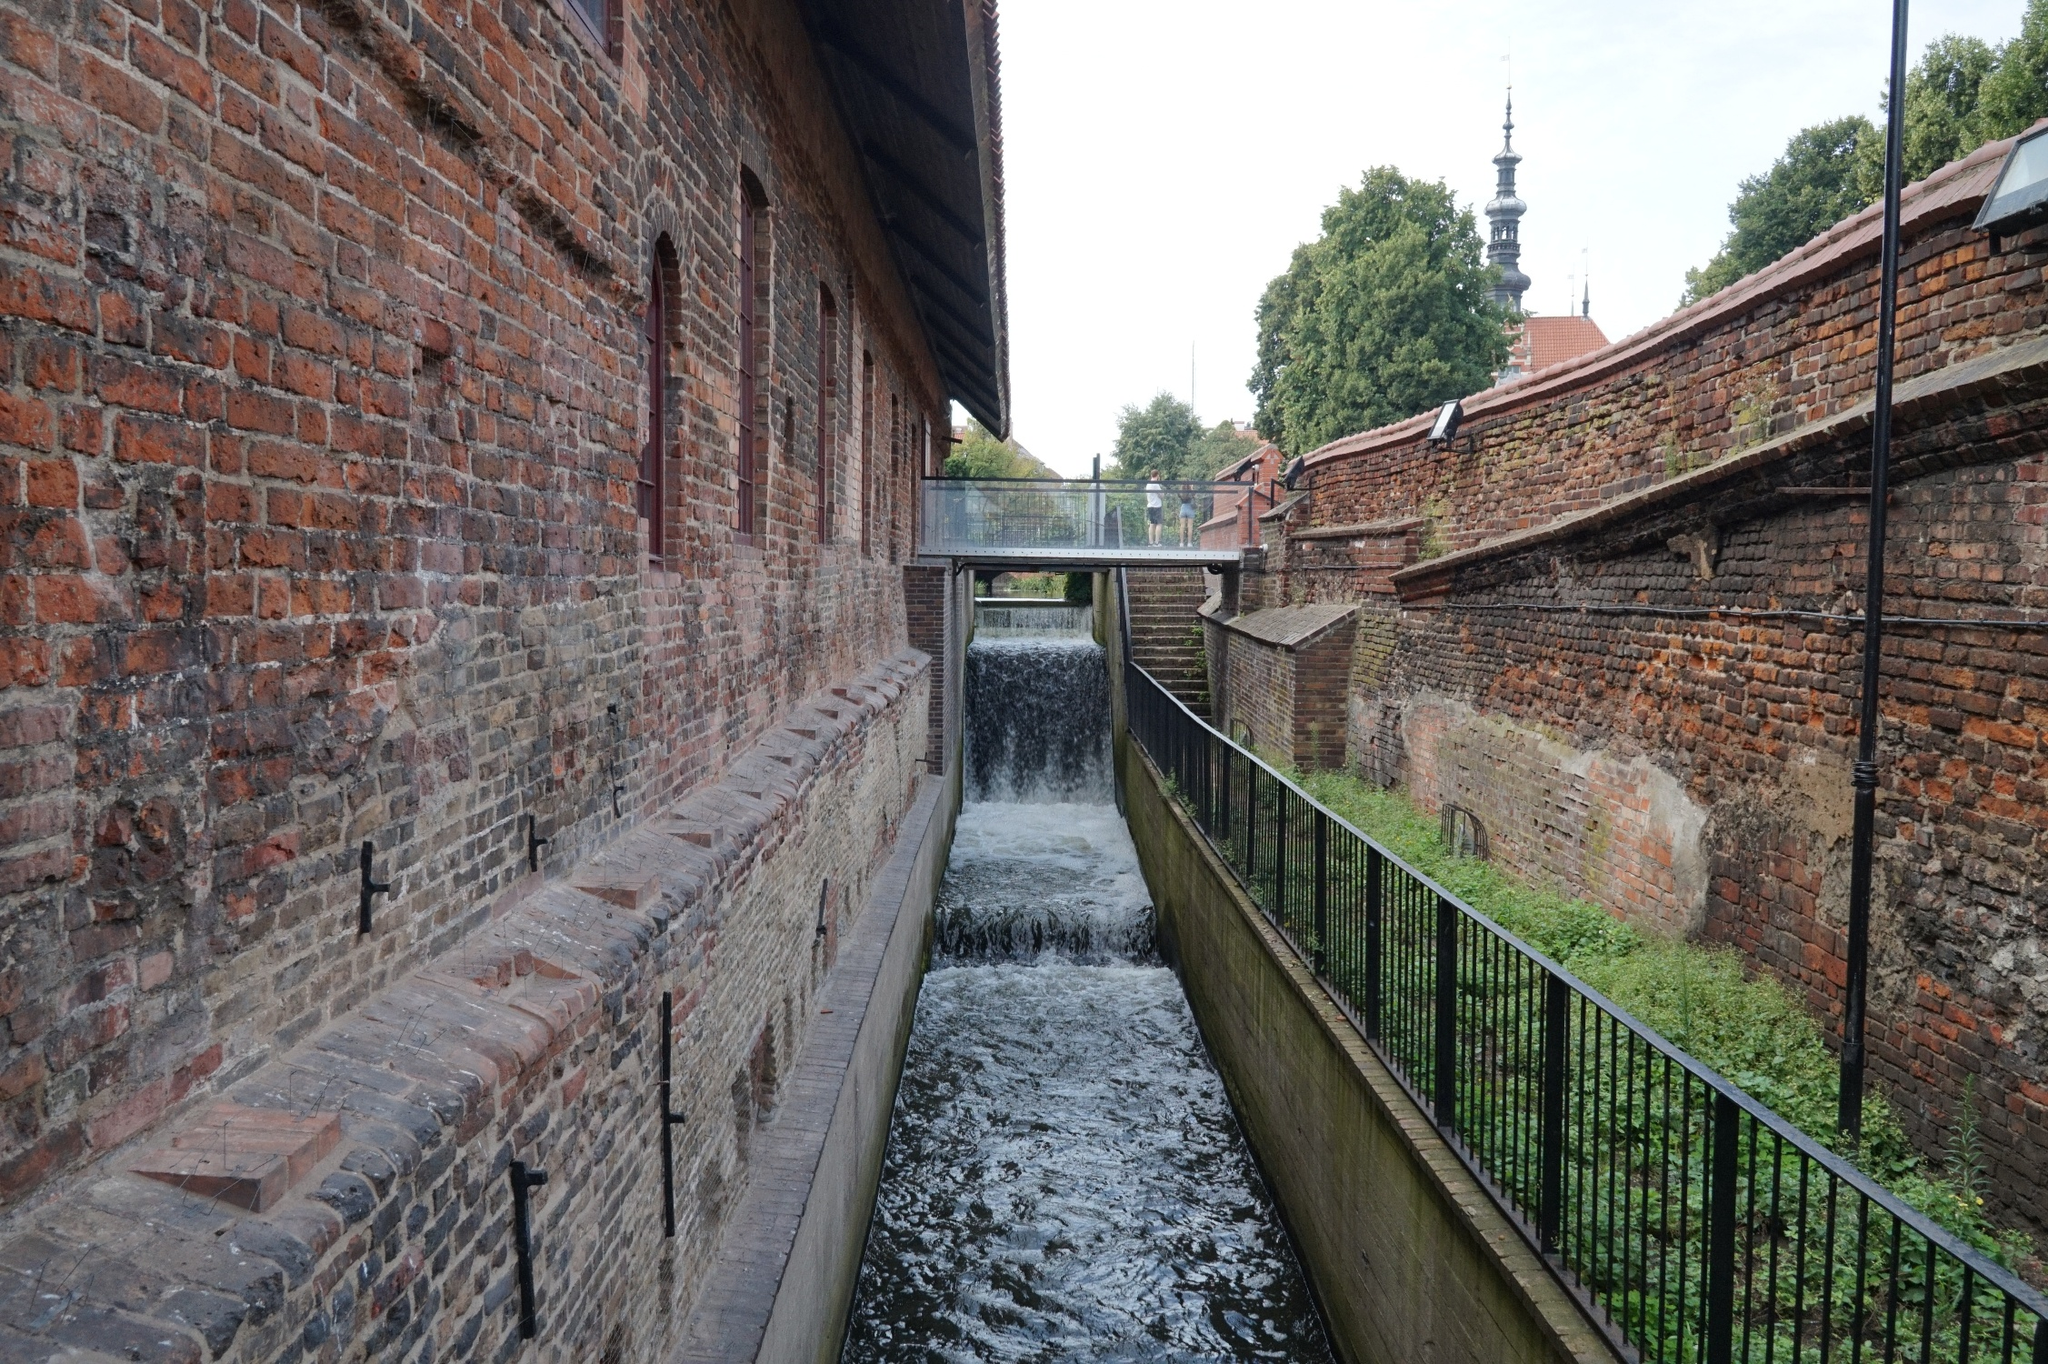What kind of atmosphere does this photo evoke? This photo evokes a peaceful and contemplative atmosphere. The serene flow of the canal, coupled with the small waterfall, adds a calming, rhythmic soundscape to the scene. The historic architecture of the brick building and church spire suggests a rich past, inviting thoughts of bygone eras. The foliage and greenery that peek through add to the tranquility, making the setting perfect for a quiet walk or reflective moment. 